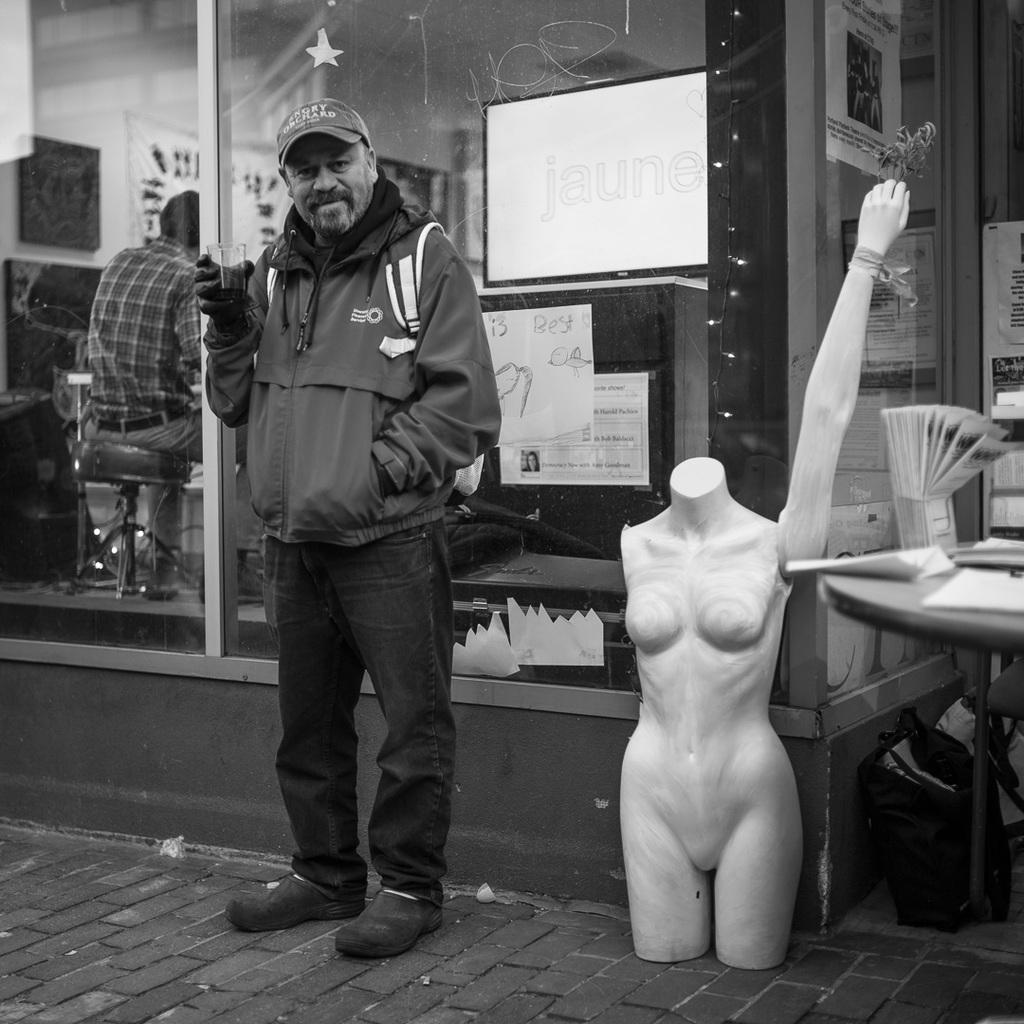Can you describe this image briefly? A man is standing here holding a glass in his hand. he wore back shoe,glove,cap and a bag. Beside him there is a toy,table and few papers. Behind him there is glass door,through the glass door we can see a man sitting on the chair and few posts attached to the glass door. 